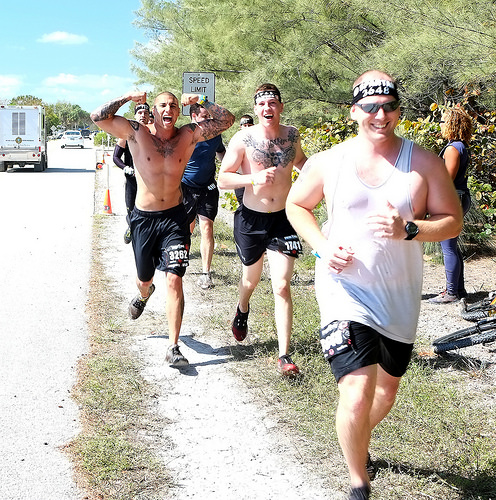<image>
Is the truck behind the man? Yes. From this viewpoint, the truck is positioned behind the man, with the man partially or fully occluding the truck. Is the man next to the man? No. The man is not positioned next to the man. They are located in different areas of the scene. 